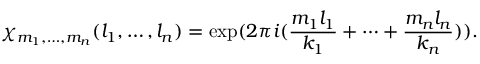<formula> <loc_0><loc_0><loc_500><loc_500>\chi _ { m _ { 1 } , \dots , m _ { n } } ( l _ { 1 } , \dots , l _ { n } ) = \exp ( 2 \pi i ( \frac { m _ { 1 } l _ { 1 } } { k _ { 1 } } + \dots + \frac { m _ { n } l _ { n } } { k _ { n } } ) ) .</formula> 